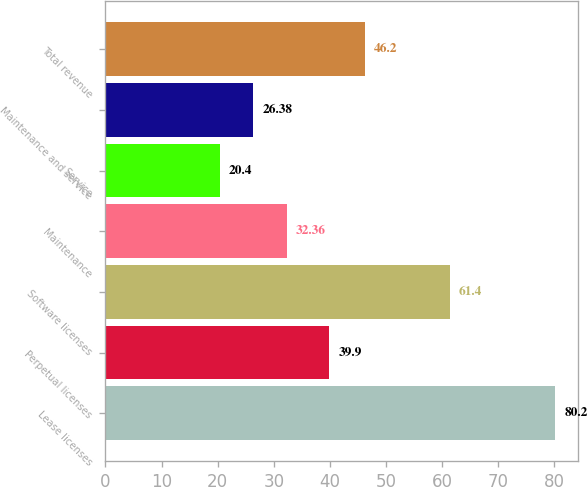<chart> <loc_0><loc_0><loc_500><loc_500><bar_chart><fcel>Lease licenses<fcel>Perpetual licenses<fcel>Software licenses<fcel>Maintenance<fcel>Service<fcel>Maintenance and service<fcel>Total revenue<nl><fcel>80.2<fcel>39.9<fcel>61.4<fcel>32.36<fcel>20.4<fcel>26.38<fcel>46.2<nl></chart> 